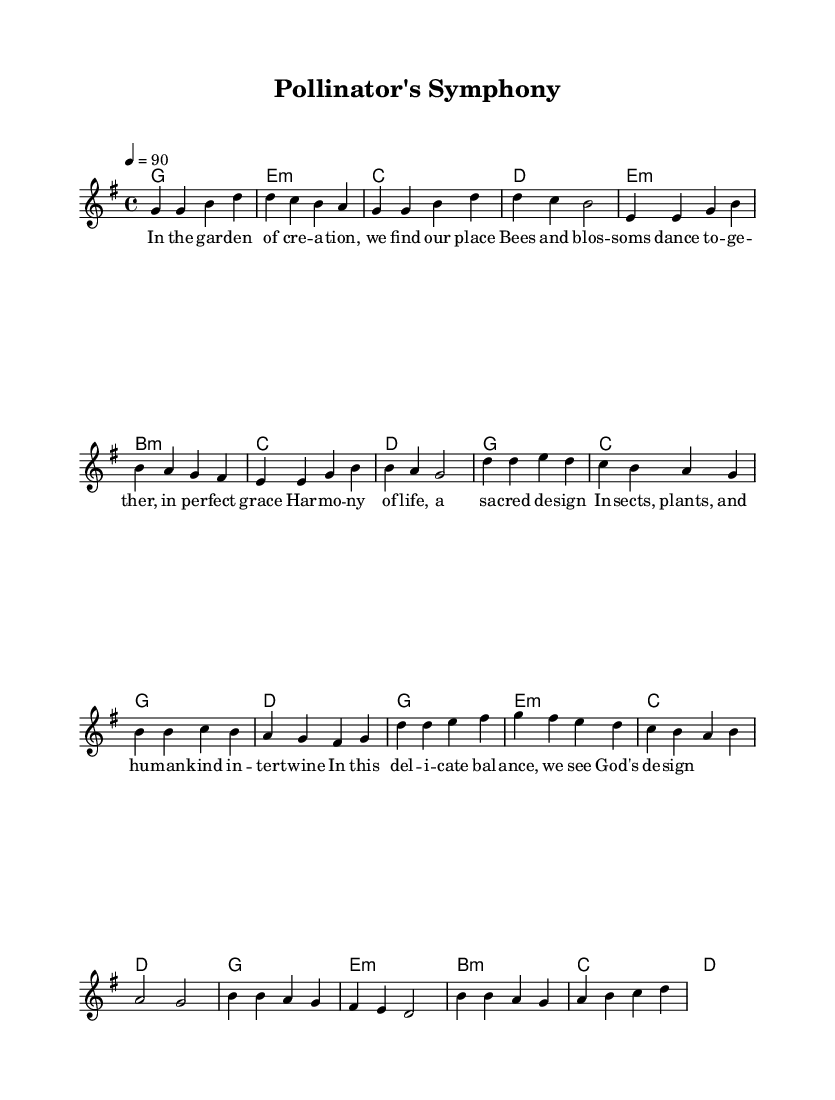What is the key signature of this music? The key signature is denoted by the sharp or flat symbols at the beginning of the staff. In this sheet music, there are no sharps or flats, indicating it is in G major.
Answer: G major What is the time signature of this music? The time signature is represented as a fraction at the beginning of the staff. Here, we see a "4/4," which indicates that there are four beats in each measure, and the quarter note gets one beat.
Answer: 4/4 What is the tempo marking for this piece? The tempo marking is shown in beats per minute and is typically notated above the staff. In this case, it states "4 = 90," which indicates the speed of the piece, meaning there are four beats per measure at a rate of 90 beats per minute.
Answer: 90 How many sections are in this piece? To determine the number of sections, we analyze the structure outlined in the score. The section labels (Verse, Chorus, Bridge) are present, indicating three distinct sections.
Answer: Three In the bridge, which note starts the melody? The bridge section starts with the note "b," as indicated by the first note in that part of the melody being played.
Answer: b What is the theme of the lyrics in this piece? The lyrics depict a relationship between humans, plants, and insects, emphasizing a divine harmony in creation. This theme signifies an interconnectedness which aligns with the idea of a symbiotic relationship.
Answer: Harmony of life How do the melody and lyrics relate to the overall message of the piece? The melody conveys an uplifting and harmonious sound that complements the lyrics' themes of collaboration and balance in nature, thus enhancing the overall religious message about the divine design in creation.
Answer: Divine design 